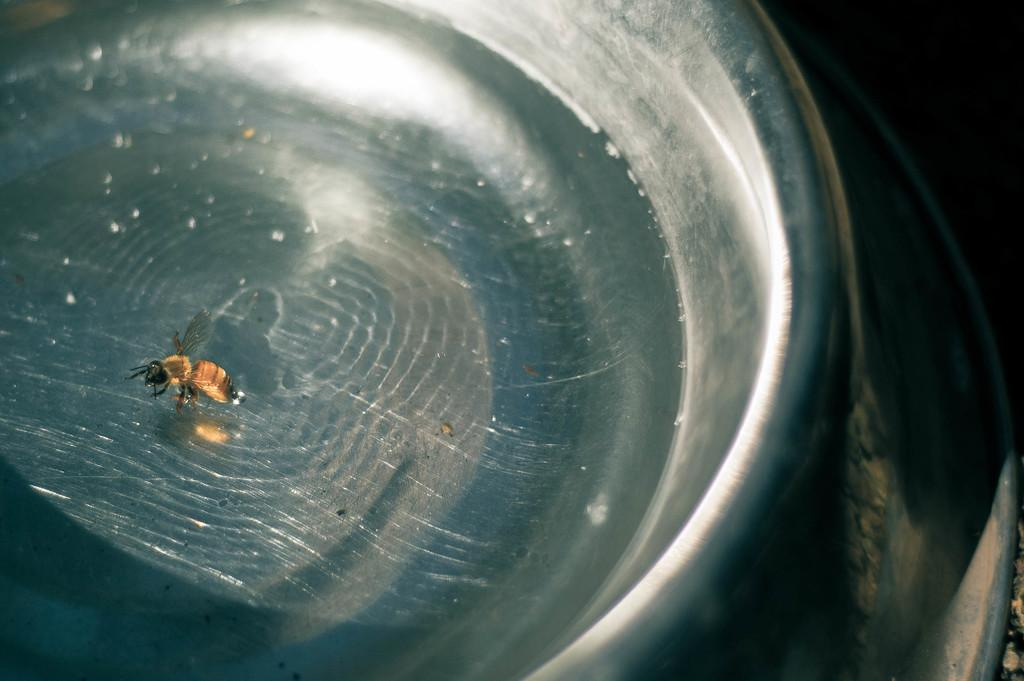What type of creature is present in the image? There is an insect in the image. What colors can be seen on the insect? The insect has black and brown color. Where is the insect located in the image? The insect is in a steel bowl. What type of honey is the insect producing in the image? There is no honey present in the image, nor is there any indication that the insect is producing honey. 